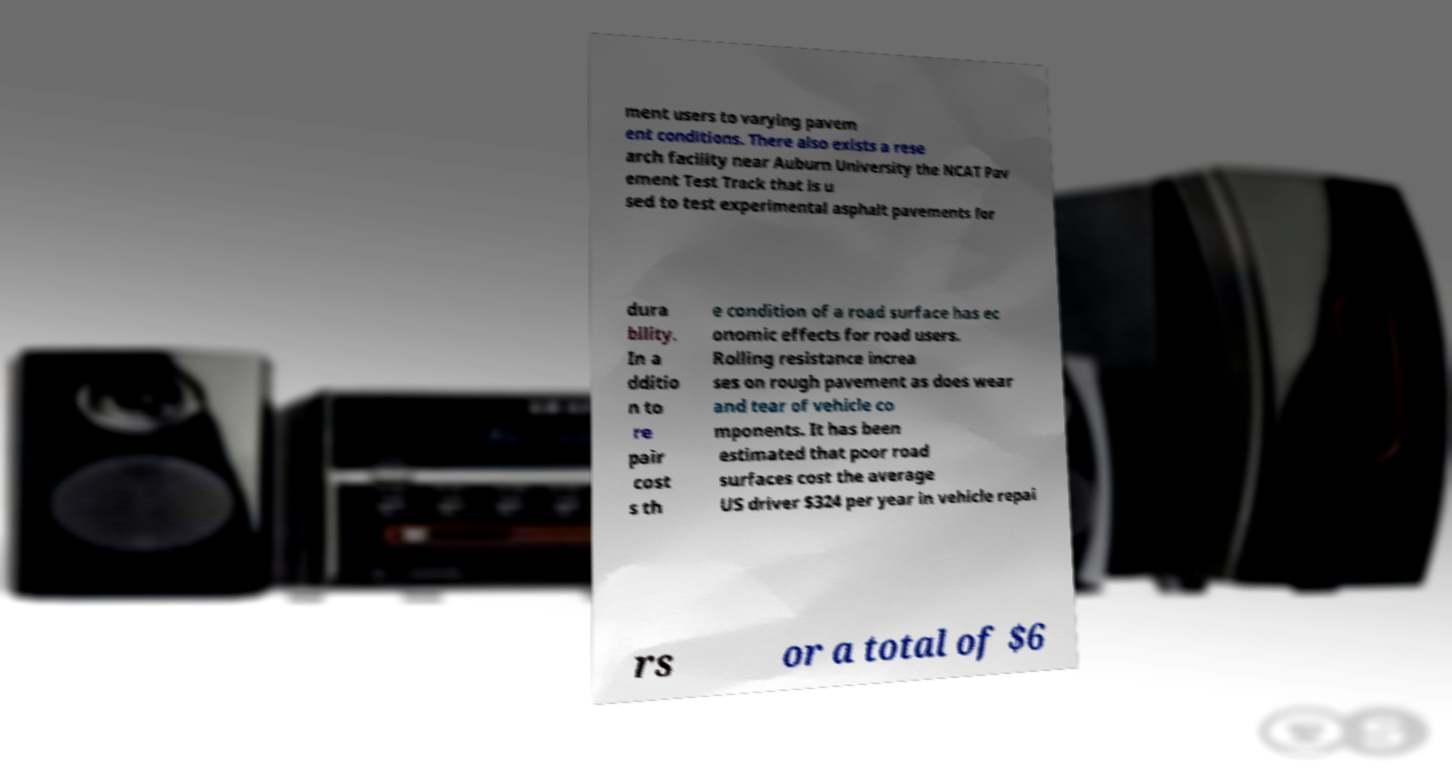I need the written content from this picture converted into text. Can you do that? ment users to varying pavem ent conditions. There also exists a rese arch facility near Auburn University the NCAT Pav ement Test Track that is u sed to test experimental asphalt pavements for dura bility. In a dditio n to re pair cost s th e condition of a road surface has ec onomic effects for road users. Rolling resistance increa ses on rough pavement as does wear and tear of vehicle co mponents. It has been estimated that poor road surfaces cost the average US driver $324 per year in vehicle repai rs or a total of $6 